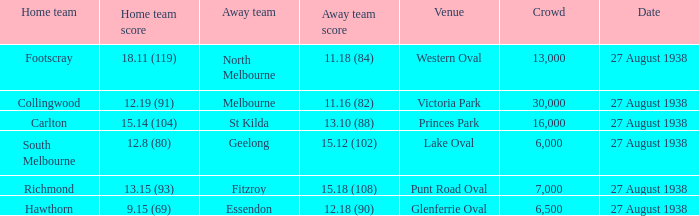15 (93)? 7000.0. 